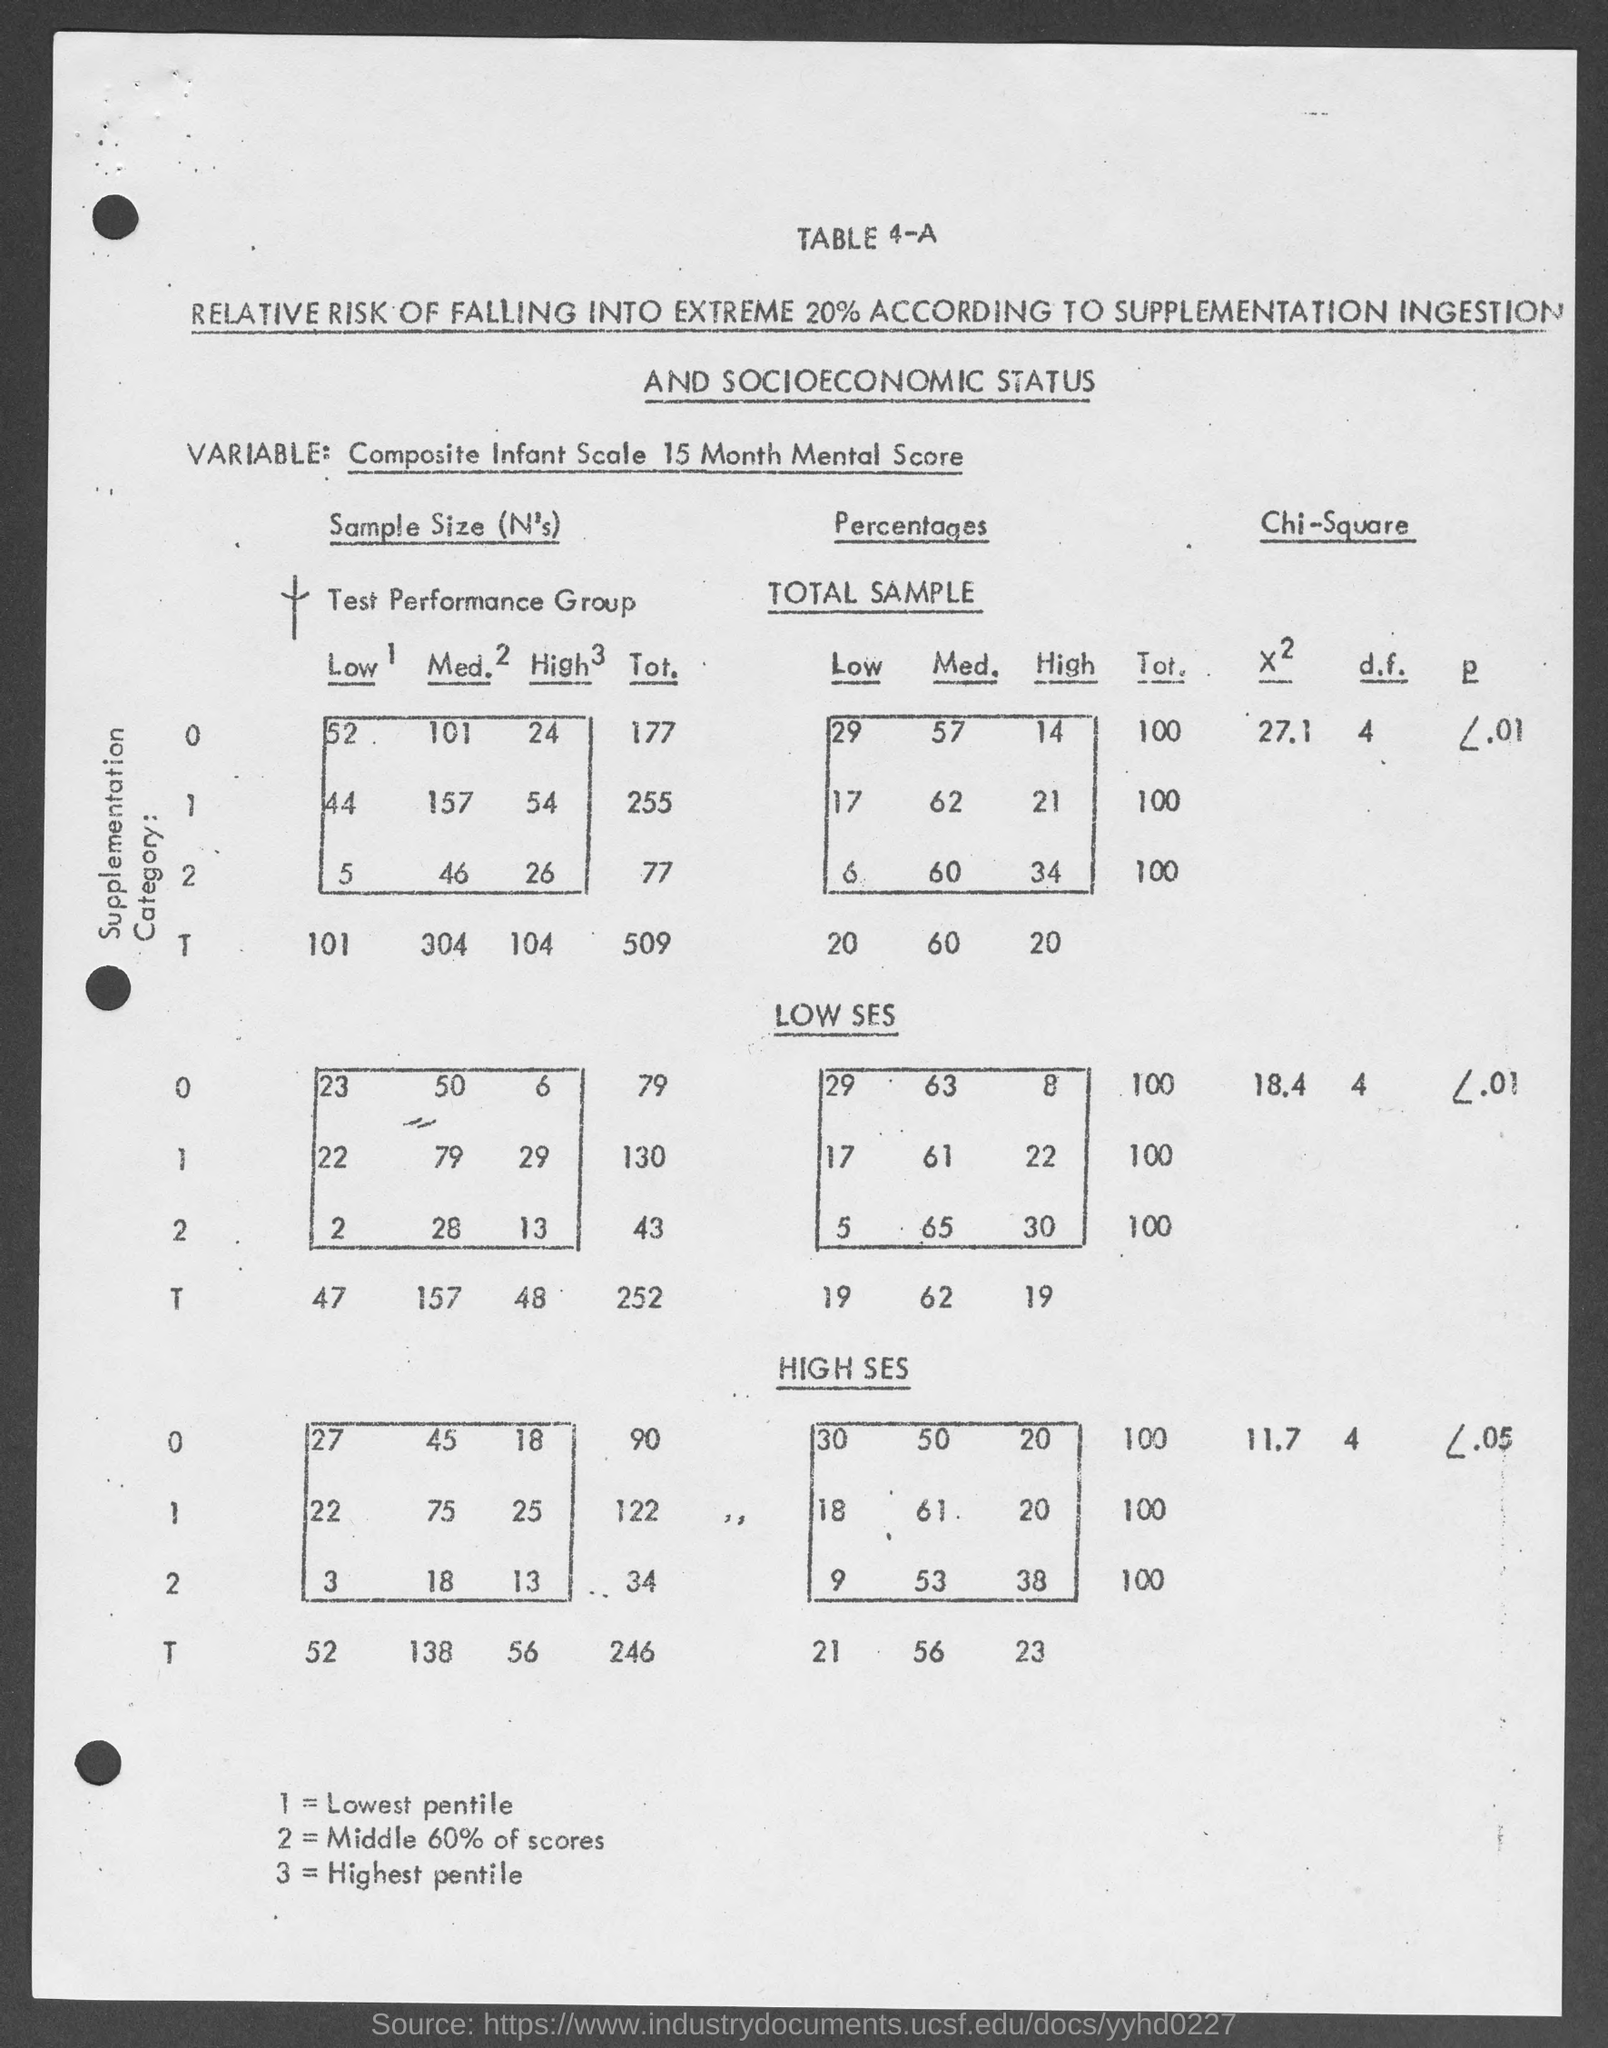Mention a couple of crucial points in this snapshot. The number "3" in the document denotes the highest pentile. The number 2 in the document refers to the middle 60% of scores. What is the table number? It is 4-a. The number "1" in the document denotes the lowest pentile. 